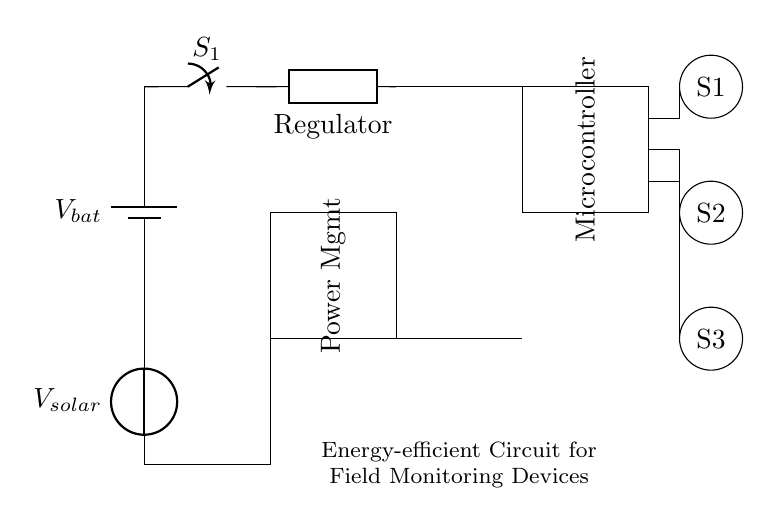What is the voltage source used in this circuit? The circuit contains two voltage sources; the main battery labeled as V bat and a solar panel labeled as V solar.
Answer: V bat and V solar What type of component is used for voltage regulation? The component labeled as VR in the circuit diagram is a voltage regulator, which ensures a stable voltage output to the microcontroller.
Answer: Regulator How many sensors are present in the circuit? There are three sensors labeled S1, S2, and S3, represented as circles in the circuit diagram.
Answer: Three What is the primary function of the power management IC? The power management IC regulates and manages power distribution to different components, optimizing energy efficiency, especially important for field monitoring devices.
Answer: Power management Which component connects the battery to the rest of the circuit? The main power switch labeled S1 connects the battery (V bat) to the voltage regulator (VR) and other components, allowing the control of power flow.
Answer: Switch Explain the relationship between the solar panel and the battery in this circuit. The solar panel (V solar) provides additional power to charge the battery (V bat) when sunlight is available, thus enhancing the longevity of the device by supplementing its energy supply.
Answer: Charging relationship What additional power source can be used in this circuit for energy efficiency? The circuit utilizes a solar panel in addition to the main battery, allowing it to harness solar energy and improve battery longevity during field operations.
Answer: Solar panel 